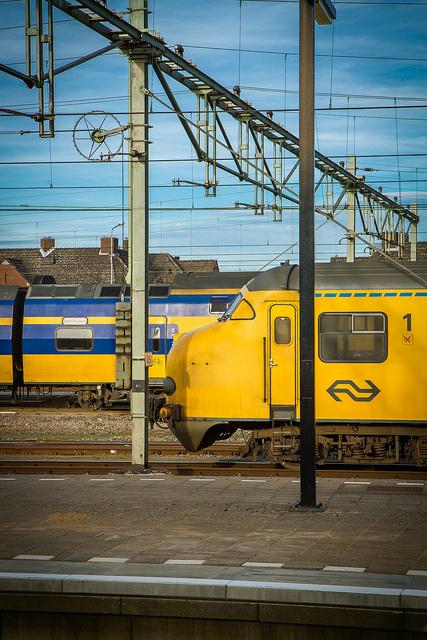Is the sky clear?
Concise answer only. Yes. How many trains are here?
Short answer required. 2. What color is the train in the background?
Give a very brief answer. Blue and yellow. 